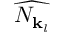Convert formula to latex. <formula><loc_0><loc_0><loc_500><loc_500>\widehat { N _ { { k } _ { l } } }</formula> 